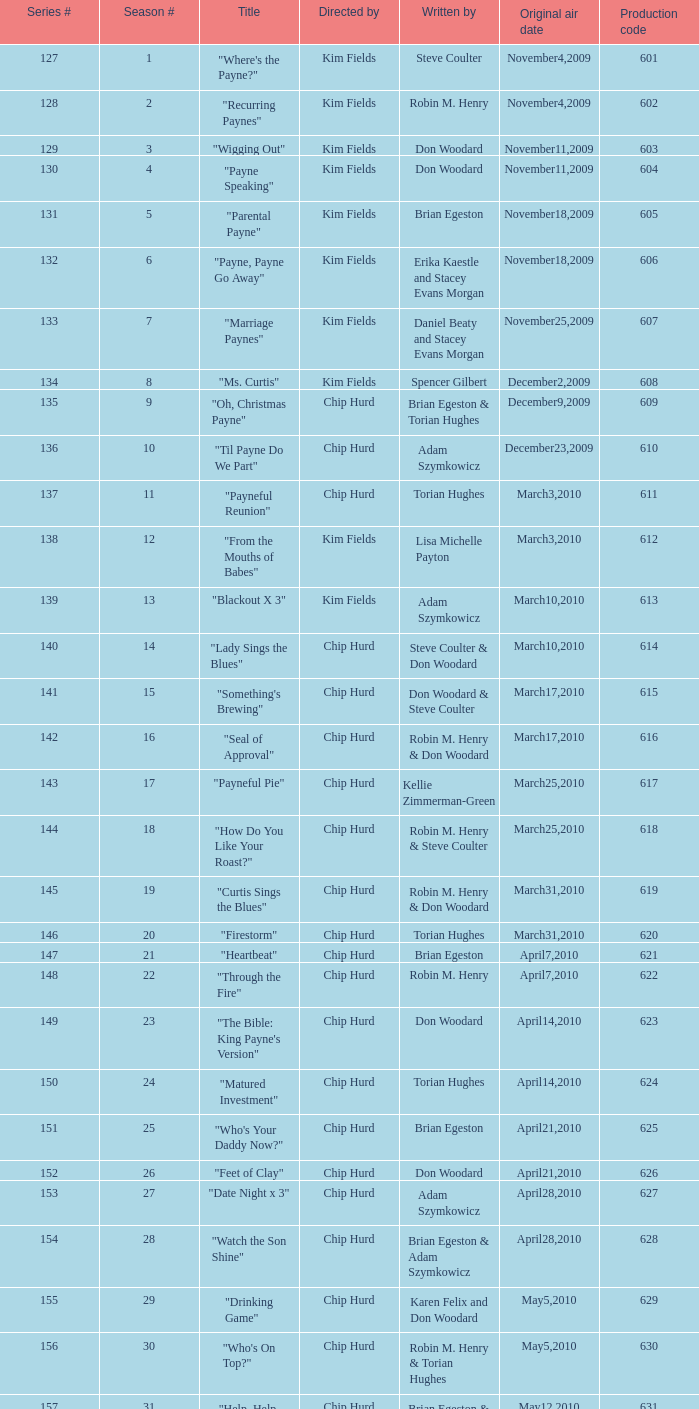Give me the full table as a dictionary. {'header': ['Series #', 'Season #', 'Title', 'Directed by', 'Written by', 'Original air date', 'Production code'], 'rows': [['127', '1', '"Where\'s the Payne?"', 'Kim Fields', 'Steve Coulter', 'November4,2009', '601'], ['128', '2', '"Recurring Paynes"', 'Kim Fields', 'Robin M. Henry', 'November4,2009', '602'], ['129', '3', '"Wigging Out"', 'Kim Fields', 'Don Woodard', 'November11,2009', '603'], ['130', '4', '"Payne Speaking"', 'Kim Fields', 'Don Woodard', 'November11,2009', '604'], ['131', '5', '"Parental Payne"', 'Kim Fields', 'Brian Egeston', 'November18,2009', '605'], ['132', '6', '"Payne, Payne Go Away"', 'Kim Fields', 'Erika Kaestle and Stacey Evans Morgan', 'November18,2009', '606'], ['133', '7', '"Marriage Paynes"', 'Kim Fields', 'Daniel Beaty and Stacey Evans Morgan', 'November25,2009', '607'], ['134', '8', '"Ms. Curtis"', 'Kim Fields', 'Spencer Gilbert', 'December2,2009', '608'], ['135', '9', '"Oh, Christmas Payne"', 'Chip Hurd', 'Brian Egeston & Torian Hughes', 'December9,2009', '609'], ['136', '10', '"Til Payne Do We Part"', 'Chip Hurd', 'Adam Szymkowicz', 'December23,2009', '610'], ['137', '11', '"Payneful Reunion"', 'Chip Hurd', 'Torian Hughes', 'March3,2010', '611'], ['138', '12', '"From the Mouths of Babes"', 'Kim Fields', 'Lisa Michelle Payton', 'March3,2010', '612'], ['139', '13', '"Blackout X 3"', 'Kim Fields', 'Adam Szymkowicz', 'March10,2010', '613'], ['140', '14', '"Lady Sings the Blues"', 'Chip Hurd', 'Steve Coulter & Don Woodard', 'March10,2010', '614'], ['141', '15', '"Something\'s Brewing"', 'Chip Hurd', 'Don Woodard & Steve Coulter', 'March17,2010', '615'], ['142', '16', '"Seal of Approval"', 'Chip Hurd', 'Robin M. Henry & Don Woodard', 'March17,2010', '616'], ['143', '17', '"Payneful Pie"', 'Chip Hurd', 'Kellie Zimmerman-Green', 'March25,2010', '617'], ['144', '18', '"How Do You Like Your Roast?"', 'Chip Hurd', 'Robin M. Henry & Steve Coulter', 'March25,2010', '618'], ['145', '19', '"Curtis Sings the Blues"', 'Chip Hurd', 'Robin M. Henry & Don Woodard', 'March31,2010', '619'], ['146', '20', '"Firestorm"', 'Chip Hurd', 'Torian Hughes', 'March31,2010', '620'], ['147', '21', '"Heartbeat"', 'Chip Hurd', 'Brian Egeston', 'April7,2010', '621'], ['148', '22', '"Through the Fire"', 'Chip Hurd', 'Robin M. Henry', 'April7,2010', '622'], ['149', '23', '"The Bible: King Payne\'s Version"', 'Chip Hurd', 'Don Woodard', 'April14,2010', '623'], ['150', '24', '"Matured Investment"', 'Chip Hurd', 'Torian Hughes', 'April14,2010', '624'], ['151', '25', '"Who\'s Your Daddy Now?"', 'Chip Hurd', 'Brian Egeston', 'April21,2010', '625'], ['152', '26', '"Feet of Clay"', 'Chip Hurd', 'Don Woodard', 'April21,2010', '626'], ['153', '27', '"Date Night x 3"', 'Chip Hurd', 'Adam Szymkowicz', 'April28,2010', '627'], ['154', '28', '"Watch the Son Shine"', 'Chip Hurd', 'Brian Egeston & Adam Szymkowicz', 'April28,2010', '628'], ['155', '29', '"Drinking Game"', 'Chip Hurd', 'Karen Felix and Don Woodard', 'May5,2010', '629'], ['156', '30', '"Who\'s On Top?"', 'Chip Hurd', 'Robin M. Henry & Torian Hughes', 'May5,2010', '630'], ['157', '31', '"Help, Help, Help"', 'Chip Hurd', 'Brian Egeston & Robin M. Henry', 'May12,2010', '631'], ['158', '32', '"Stinging Payne"', 'Chip Hurd', 'Don Woodard', 'May12,2010', '632'], ['159', '33', '"Worth Fighting For"', 'Chip Hurd', 'Torian Hughes', 'May19,2010', '633'], ['160', '34', '"Who\'s Your Nanny?"', 'Chip Hurd', 'Robin M. Henry & Adam Szymkowicz', 'May19,2010', '634'], ['161', '35', '"The Chef"', 'Chip Hurd', 'Anthony C. Hill', 'May26,2010', '635'], ['162', '36', '"My Fair Curtis"', 'Chip Hurd', 'Don Woodard', 'May26,2010', '636'], ['163', '37', '"Rest for the Weary"', 'Chip Hurd', 'Brian Egeston', 'June2,2010', '637'], ['164', '38', '"Thug Life"', 'Chip Hurd', 'Torian Hughes', 'June2,2010', '638'], ['165', '39', '"Rehabilitation"', 'Chip Hurd', 'Adam Szymkowicz', 'June9,2010', '639'], ['166', '40', '"A Payne In Need Is A Pain Indeed"', 'Chip Hurd', 'Don Woodard', 'June9,2010', '640'], ['167', '41', '"House Guest"', 'Chip Hurd', 'David A. Arnold', 'January5,2011', '641'], ['168', '42', '"Payne Showers"', 'Chip Hurd', 'Omega Mariaunnie Stewart and Torian Hughes', 'January5,2011', '642'], ['169', '43', '"Playing With Fire"', 'Chip Hurd', 'Carlos Portugal', 'January12,2011', '643'], ['170', '44', '"When the Payne\'s Away"', 'Chip Hurd', 'Kristin Topps and Don Woodard', 'January12,2011', '644'], ['171', '45', '"Beginnings"', 'Chip Hurd', 'Myra J.', 'January19,2011', '645']]} What is the original air date of the episode written by Karen Felix and Don Woodard? May5,2010. 